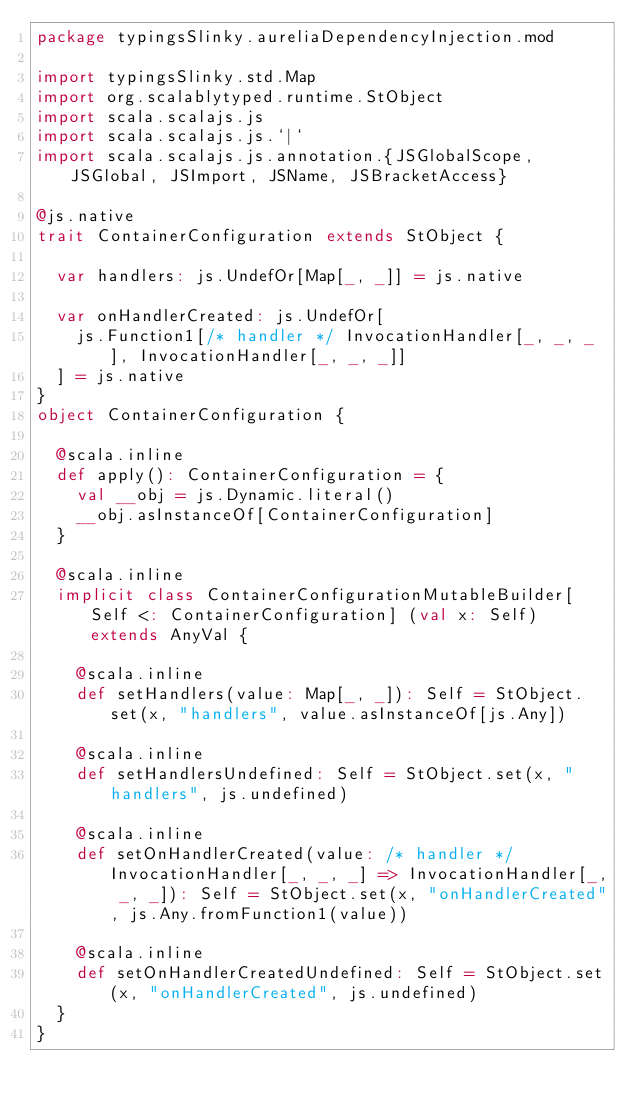<code> <loc_0><loc_0><loc_500><loc_500><_Scala_>package typingsSlinky.aureliaDependencyInjection.mod

import typingsSlinky.std.Map
import org.scalablytyped.runtime.StObject
import scala.scalajs.js
import scala.scalajs.js.`|`
import scala.scalajs.js.annotation.{JSGlobalScope, JSGlobal, JSImport, JSName, JSBracketAccess}

@js.native
trait ContainerConfiguration extends StObject {
  
  var handlers: js.UndefOr[Map[_, _]] = js.native
  
  var onHandlerCreated: js.UndefOr[
    js.Function1[/* handler */ InvocationHandler[_, _, _], InvocationHandler[_, _, _]]
  ] = js.native
}
object ContainerConfiguration {
  
  @scala.inline
  def apply(): ContainerConfiguration = {
    val __obj = js.Dynamic.literal()
    __obj.asInstanceOf[ContainerConfiguration]
  }
  
  @scala.inline
  implicit class ContainerConfigurationMutableBuilder[Self <: ContainerConfiguration] (val x: Self) extends AnyVal {
    
    @scala.inline
    def setHandlers(value: Map[_, _]): Self = StObject.set(x, "handlers", value.asInstanceOf[js.Any])
    
    @scala.inline
    def setHandlersUndefined: Self = StObject.set(x, "handlers", js.undefined)
    
    @scala.inline
    def setOnHandlerCreated(value: /* handler */ InvocationHandler[_, _, _] => InvocationHandler[_, _, _]): Self = StObject.set(x, "onHandlerCreated", js.Any.fromFunction1(value))
    
    @scala.inline
    def setOnHandlerCreatedUndefined: Self = StObject.set(x, "onHandlerCreated", js.undefined)
  }
}
</code> 